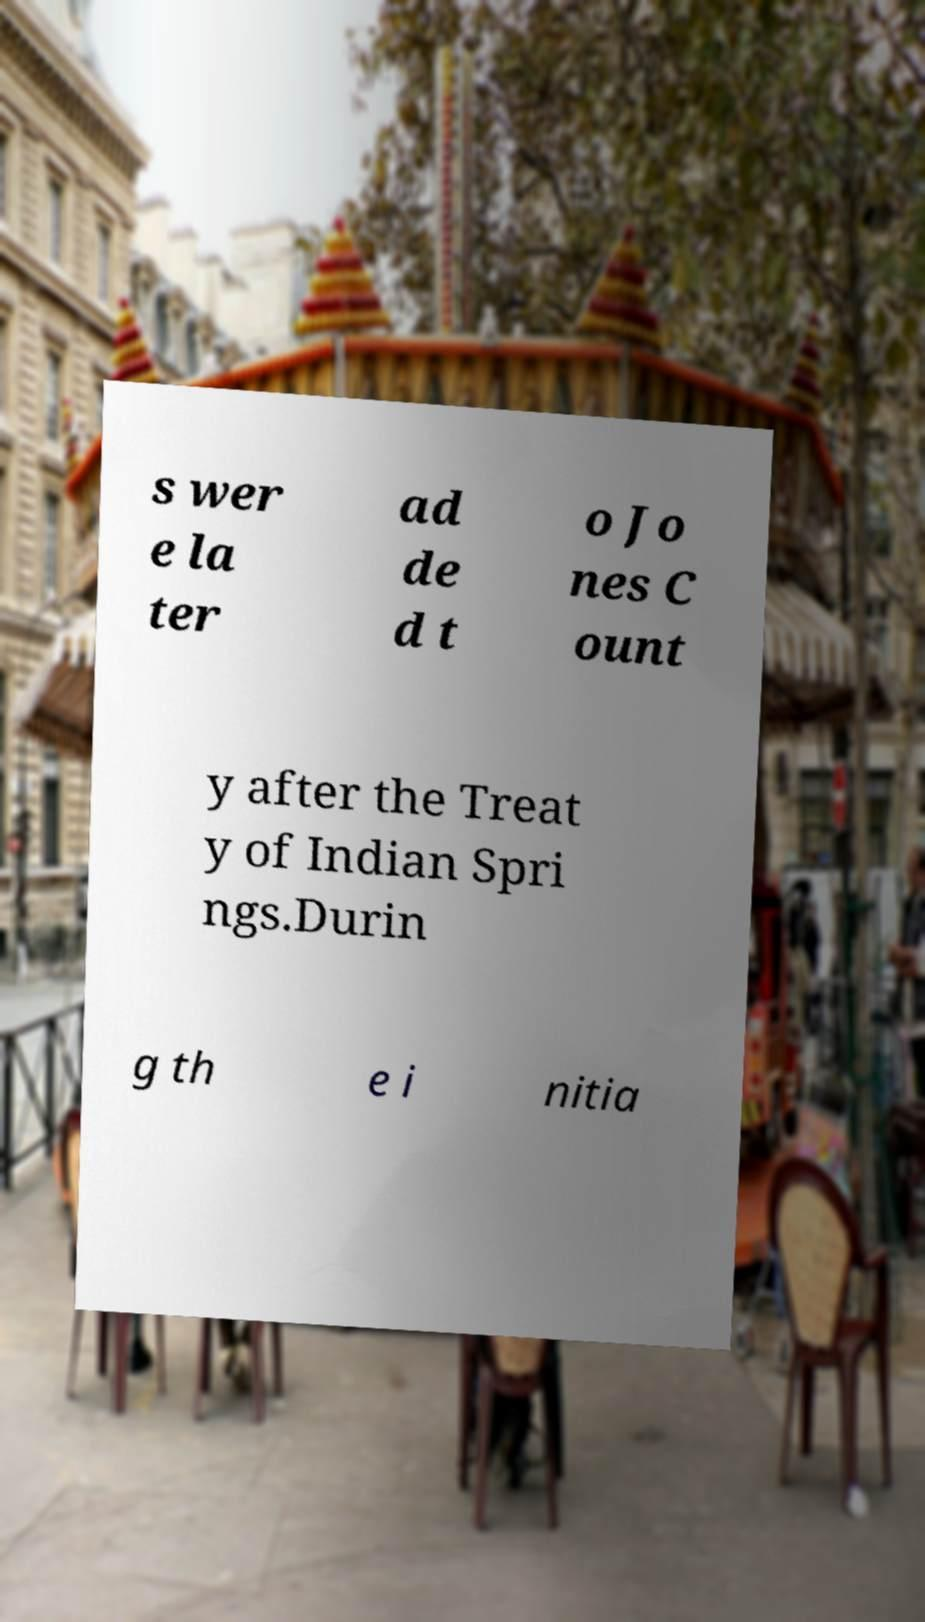Could you assist in decoding the text presented in this image and type it out clearly? s wer e la ter ad de d t o Jo nes C ount y after the Treat y of Indian Spri ngs.Durin g th e i nitia 